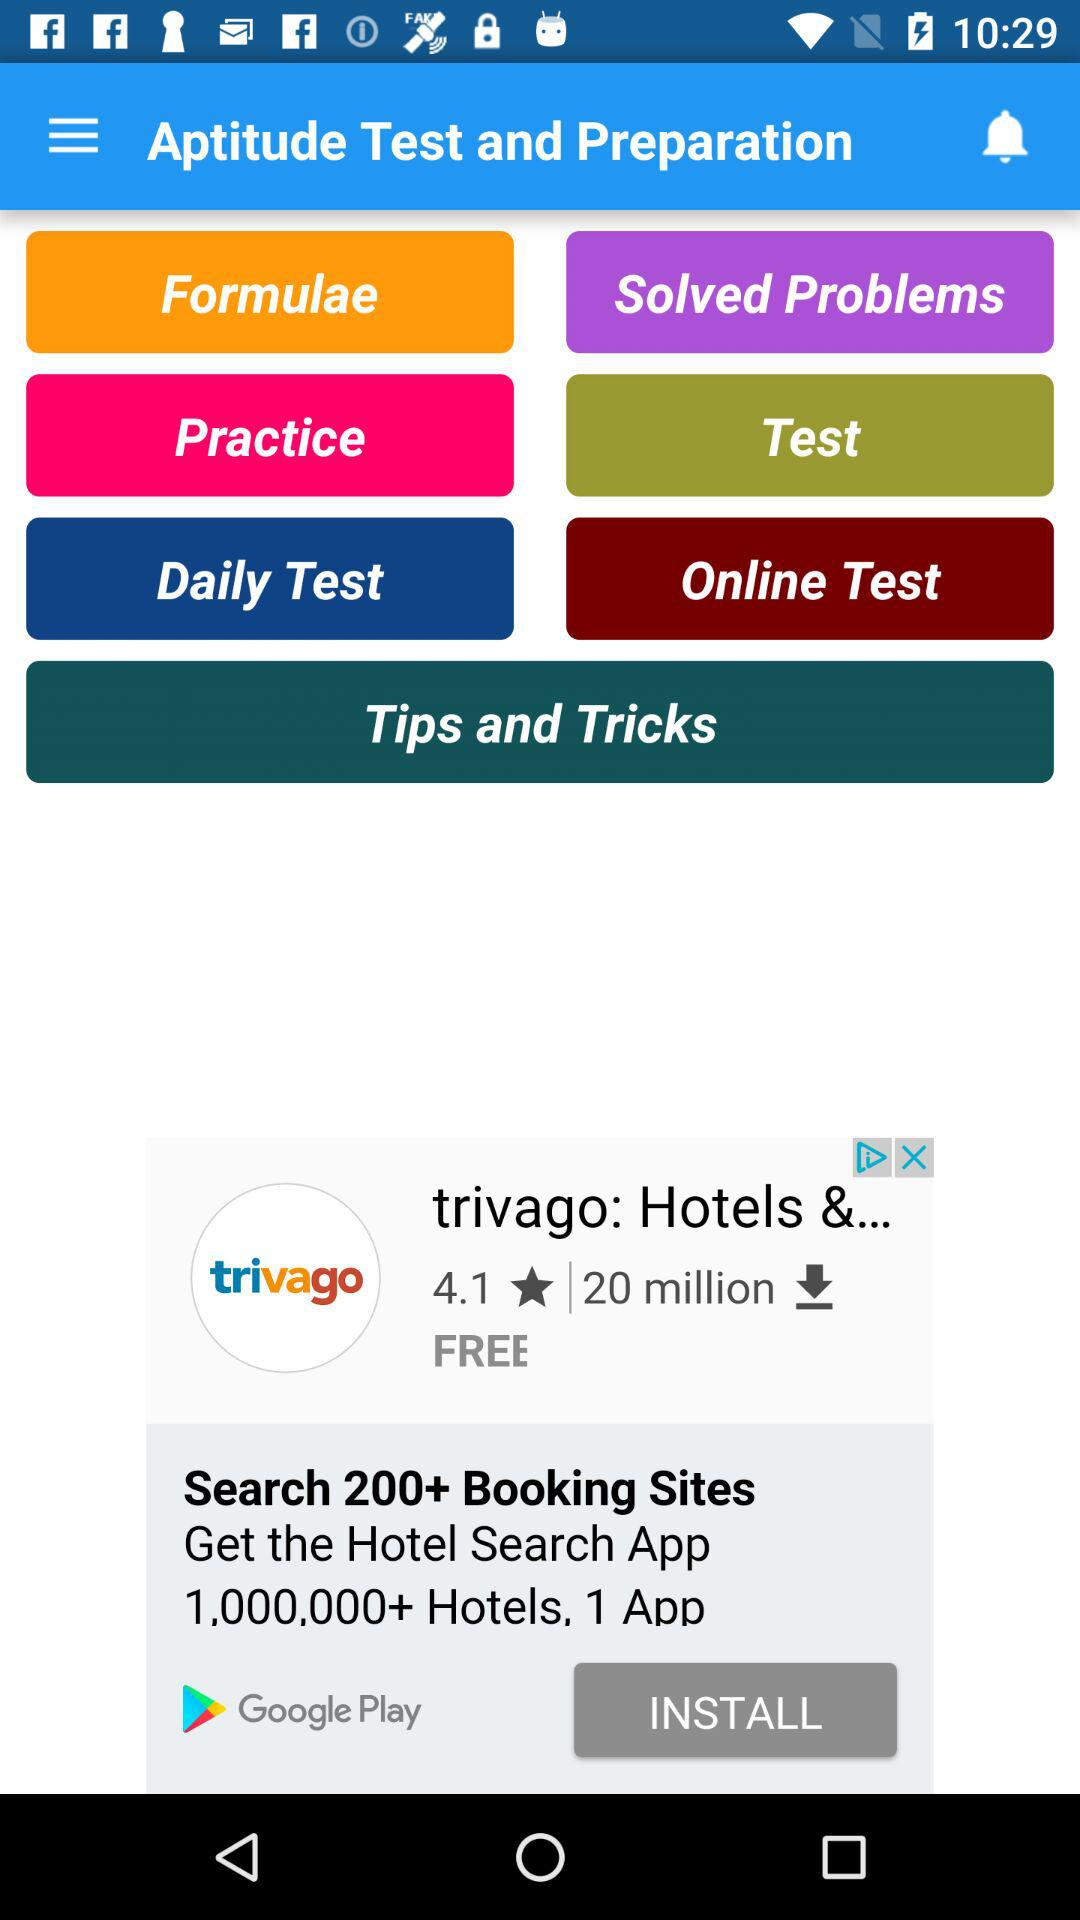What is the application name? The application name is "Aptitude Test and Preparation". 